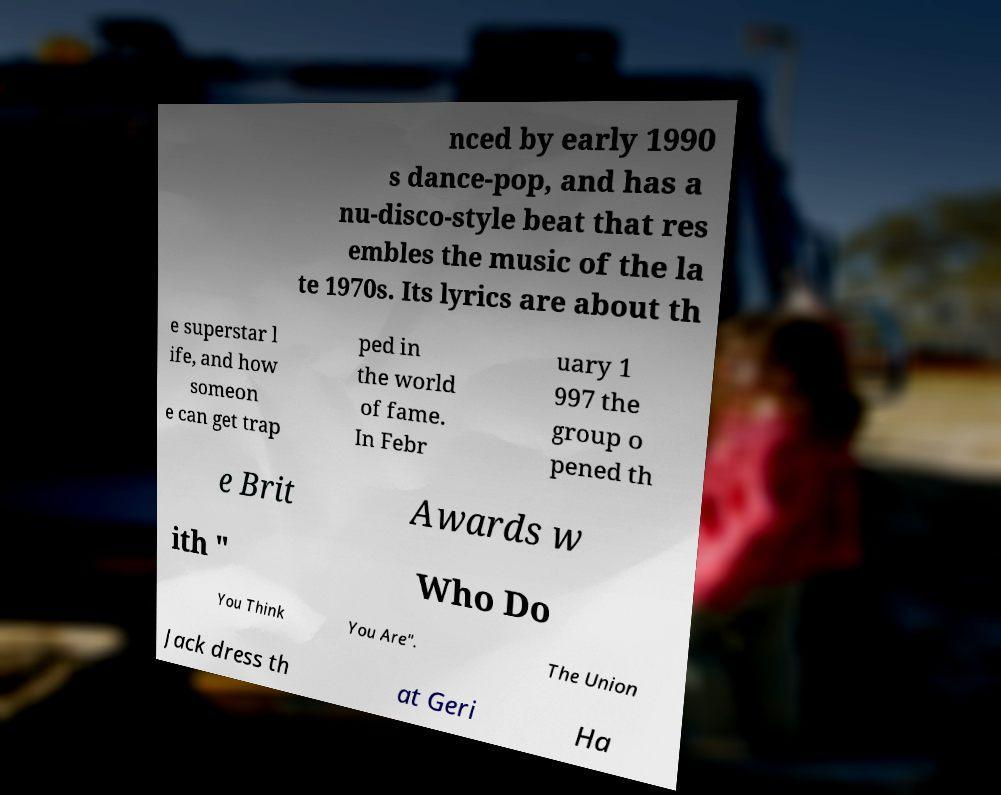Could you extract and type out the text from this image? nced by early 1990 s dance-pop, and has a nu-disco-style beat that res embles the music of the la te 1970s. Its lyrics are about th e superstar l ife, and how someon e can get trap ped in the world of fame. In Febr uary 1 997 the group o pened th e Brit Awards w ith " Who Do You Think You Are". The Union Jack dress th at Geri Ha 